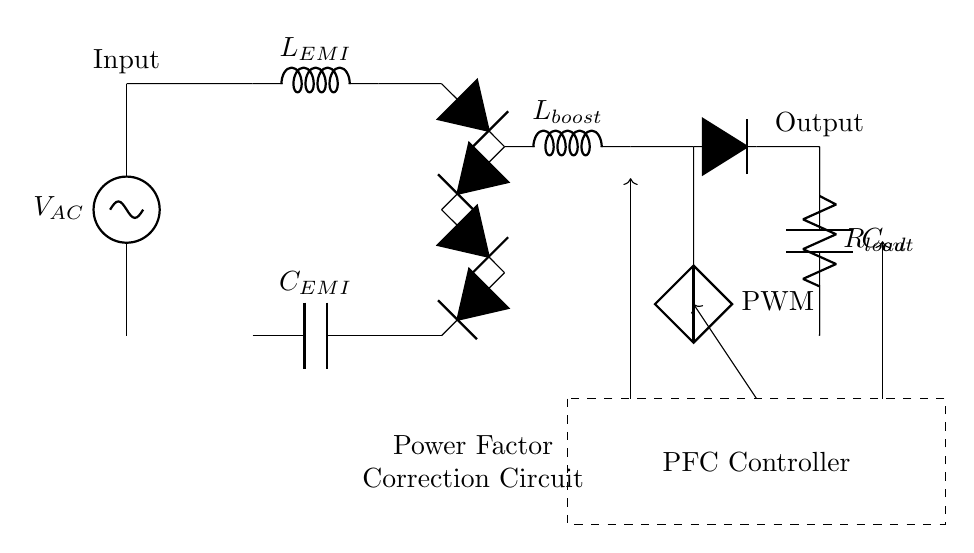What is the input voltage of the circuit? The input voltage is represented by the label next to the AC source, which is denoted as V_AC. This indicates the voltage supplied from an alternating current source.
Answer: V_AC What type of controller is used in this circuit? The circuit diagram has a labeled section for the PFC Controller, which is the component responsible for managing power factor correction.
Answer: PFC Controller How many diodes are in the bridge rectifier? By counting the symbols marked as D* in the diagram, we see there are four diodes used in the bridge rectifier configuration.
Answer: Four What is the purpose of the capacitors in this circuit? The circuit includes two capacitors, C_EMI and C_out. C_EMI serves to filter electromagnetic interference, while C_out is used for output smoothing, improving overall efficiency.
Answer: Filter and smoothing Which components are responsible for energy storage in this circuit? The circuit contains two inductors, L_EMI and L_boost, and two capacitors, C_EMI and C_out, all of which serve energy storage roles in the circuit's operation.
Answer: L_EMI, L_boost, C_EMI, C_out What is the function of the boost converter in this circuit? The boost converter, represented in the diagram, steps up the voltage after the rectification process to ensure that the load receives the necessary higher voltage level for proper operation.
Answer: Step-up voltage 